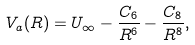<formula> <loc_0><loc_0><loc_500><loc_500>V _ { a } ( R ) = U _ { \infty } - \frac { C _ { 6 } } { R ^ { 6 } } - \frac { C _ { 8 } } { R ^ { 8 } } ,</formula> 